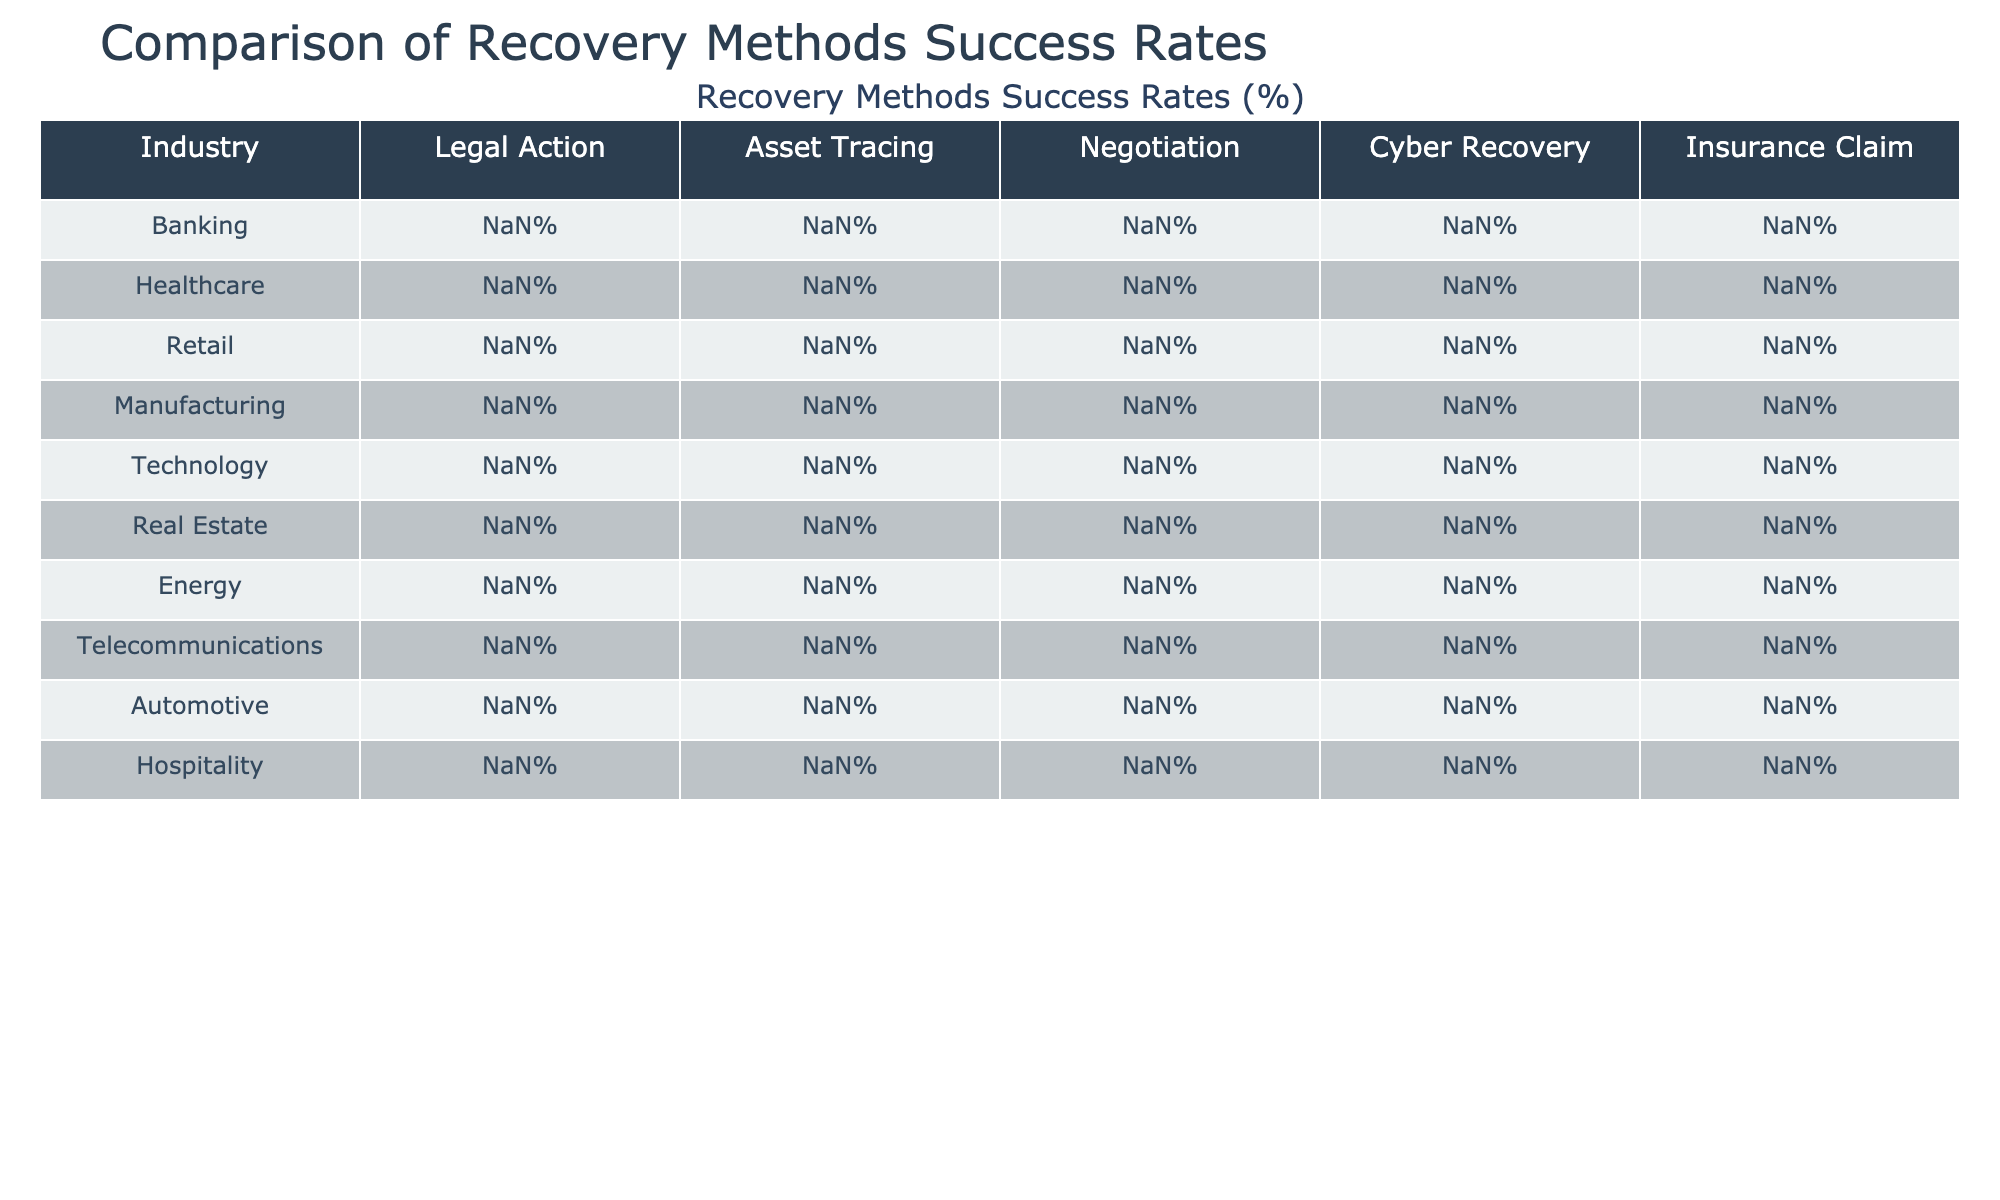What is the success rate of Asset Tracing in the Technology industry? The table shows that the success rate of Asset Tracing for the Technology industry is 88%.
Answer: 88% Which recovery method has the highest success rate in the Banking industry? In the Banking industry, the method with the highest success rate is Asset Tracing, which is at 85%.
Answer: Asset Tracing What is the average success rate of Cyber Recovery across all industries? The success rates for Cyber Recovery are 78%, 82%, 75%, 73%, 86%, 71%, 76%, 80%, 74%, and 72% for each industry respectively. To find the average, we sum these rates (78+82+75+73+86+71+76+80+74+72 =  785) and divide by the number of industries (10) which gives us 785/10 = 78.5%.
Answer: 78.5% Is the success rate of Negotiation higher in the Manufacturing industry than in the Healthcare industry? The success rate of Negotiation in Manufacturing is 59% and in Healthcare it is 58%. 59% is higher than 58%, therefore, the success rate in Manufacturing is indeed higher.
Answer: Yes Which industry has the lowest success rate in Legal Action? Reviewing the table, the lowest success rate in Legal Action is found in the Hospitality industry, at 64%.
Answer: Hospitality What is the difference between the success rates of Cyber Recovery in the Technology and Automotive industries? The success rate of Cyber Recovery in Technology is 86% and in Automotive it is 74%. The difference is calculated as 86% - 74% = 12%.
Answer: 12% Does the Telecommunications industry have a higher success rate for Insurance Claims compared to the Retail industry? The success rate for Insurance Claims in Telecommunications is 69%, while in Retail it is 67%. Since 69% is greater than 67%, this statement is true.
Answer: Yes What is the total success rate of Legal Action for all industries combined? The success rates for Legal Action are 72%, 65%, 68%, 70%, 75%, 69%, 71%, 73%, 67%, and 64%. Summing these (72+65+68+70+75+69+71+73+67+64 =  674) and dividing by the number of industries (10) gives an average of 67.4%.
Answer: 67.4% In which recovery method does the Energy industry have the lowest success rate? The table indicates that the Energy industry has the lowest success rate in Negotiation, which is at 60%.
Answer: Negotiation What is the highest success rate for Legal Action and which industry achieves it? The highest success rate for Legal Action is 75%, achieved by the Technology industry.
Answer: Technology 